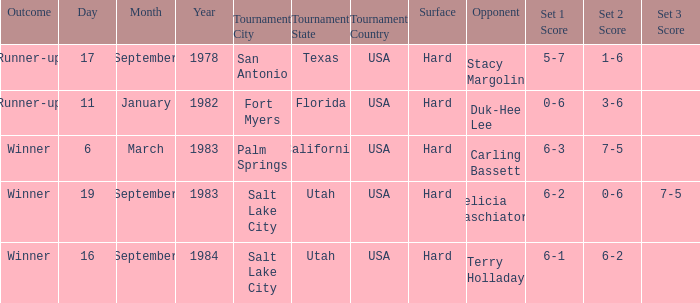What was the score of the match against duk-hee lee? 0-6, 3-6. 